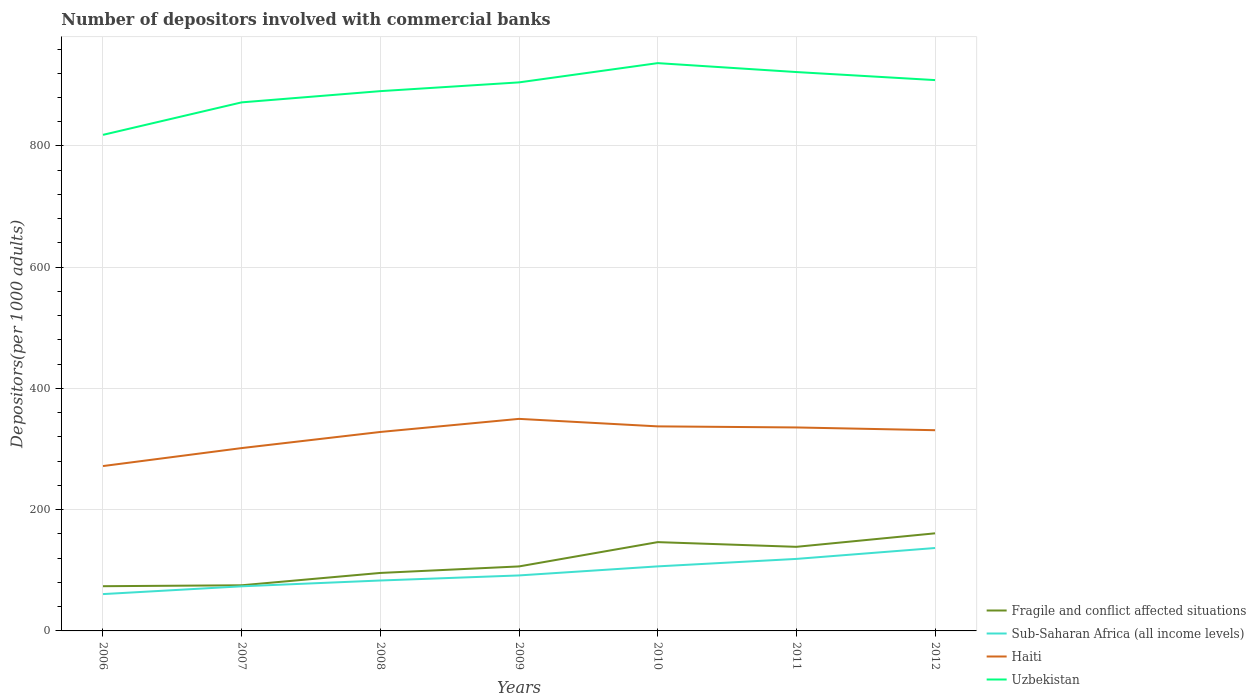How many different coloured lines are there?
Provide a succinct answer. 4. Does the line corresponding to Sub-Saharan Africa (all income levels) intersect with the line corresponding to Uzbekistan?
Your answer should be very brief. No. Across all years, what is the maximum number of depositors involved with commercial banks in Sub-Saharan Africa (all income levels)?
Your response must be concise. 60.76. What is the total number of depositors involved with commercial banks in Sub-Saharan Africa (all income levels) in the graph?
Make the answer very short. -45.73. What is the difference between the highest and the second highest number of depositors involved with commercial banks in Uzbekistan?
Give a very brief answer. 118.34. Are the values on the major ticks of Y-axis written in scientific E-notation?
Provide a short and direct response. No. Where does the legend appear in the graph?
Provide a short and direct response. Bottom right. How many legend labels are there?
Offer a terse response. 4. How are the legend labels stacked?
Your answer should be very brief. Vertical. What is the title of the graph?
Ensure brevity in your answer.  Number of depositors involved with commercial banks. What is the label or title of the Y-axis?
Offer a terse response. Depositors(per 1000 adults). What is the Depositors(per 1000 adults) in Fragile and conflict affected situations in 2006?
Offer a terse response. 73.77. What is the Depositors(per 1000 adults) of Sub-Saharan Africa (all income levels) in 2006?
Provide a short and direct response. 60.76. What is the Depositors(per 1000 adults) of Haiti in 2006?
Your answer should be compact. 271.98. What is the Depositors(per 1000 adults) of Uzbekistan in 2006?
Your answer should be compact. 818.38. What is the Depositors(per 1000 adults) in Fragile and conflict affected situations in 2007?
Provide a short and direct response. 75.3. What is the Depositors(per 1000 adults) in Sub-Saharan Africa (all income levels) in 2007?
Make the answer very short. 73.6. What is the Depositors(per 1000 adults) of Haiti in 2007?
Keep it short and to the point. 301.64. What is the Depositors(per 1000 adults) in Uzbekistan in 2007?
Ensure brevity in your answer.  871.99. What is the Depositors(per 1000 adults) of Fragile and conflict affected situations in 2008?
Your answer should be compact. 95.65. What is the Depositors(per 1000 adults) in Sub-Saharan Africa (all income levels) in 2008?
Give a very brief answer. 83.18. What is the Depositors(per 1000 adults) in Haiti in 2008?
Make the answer very short. 328.23. What is the Depositors(per 1000 adults) of Uzbekistan in 2008?
Your response must be concise. 890.51. What is the Depositors(per 1000 adults) in Fragile and conflict affected situations in 2009?
Make the answer very short. 106.41. What is the Depositors(per 1000 adults) in Sub-Saharan Africa (all income levels) in 2009?
Offer a very short reply. 91.54. What is the Depositors(per 1000 adults) in Haiti in 2009?
Make the answer very short. 349.83. What is the Depositors(per 1000 adults) of Uzbekistan in 2009?
Give a very brief answer. 904.94. What is the Depositors(per 1000 adults) of Fragile and conflict affected situations in 2010?
Your answer should be very brief. 146.5. What is the Depositors(per 1000 adults) of Sub-Saharan Africa (all income levels) in 2010?
Ensure brevity in your answer.  106.49. What is the Depositors(per 1000 adults) in Haiti in 2010?
Your answer should be very brief. 337.45. What is the Depositors(per 1000 adults) of Uzbekistan in 2010?
Keep it short and to the point. 936.72. What is the Depositors(per 1000 adults) of Fragile and conflict affected situations in 2011?
Give a very brief answer. 138.74. What is the Depositors(per 1000 adults) in Sub-Saharan Africa (all income levels) in 2011?
Offer a terse response. 118.8. What is the Depositors(per 1000 adults) in Haiti in 2011?
Offer a very short reply. 335.67. What is the Depositors(per 1000 adults) in Uzbekistan in 2011?
Your response must be concise. 921.99. What is the Depositors(per 1000 adults) in Fragile and conflict affected situations in 2012?
Ensure brevity in your answer.  161.02. What is the Depositors(per 1000 adults) in Sub-Saharan Africa (all income levels) in 2012?
Your response must be concise. 136.78. What is the Depositors(per 1000 adults) of Haiti in 2012?
Offer a very short reply. 331.14. What is the Depositors(per 1000 adults) in Uzbekistan in 2012?
Give a very brief answer. 908.73. Across all years, what is the maximum Depositors(per 1000 adults) of Fragile and conflict affected situations?
Offer a terse response. 161.02. Across all years, what is the maximum Depositors(per 1000 adults) in Sub-Saharan Africa (all income levels)?
Offer a very short reply. 136.78. Across all years, what is the maximum Depositors(per 1000 adults) in Haiti?
Offer a terse response. 349.83. Across all years, what is the maximum Depositors(per 1000 adults) in Uzbekistan?
Ensure brevity in your answer.  936.72. Across all years, what is the minimum Depositors(per 1000 adults) in Fragile and conflict affected situations?
Your answer should be very brief. 73.77. Across all years, what is the minimum Depositors(per 1000 adults) in Sub-Saharan Africa (all income levels)?
Provide a short and direct response. 60.76. Across all years, what is the minimum Depositors(per 1000 adults) of Haiti?
Your answer should be very brief. 271.98. Across all years, what is the minimum Depositors(per 1000 adults) of Uzbekistan?
Keep it short and to the point. 818.38. What is the total Depositors(per 1000 adults) of Fragile and conflict affected situations in the graph?
Offer a terse response. 797.39. What is the total Depositors(per 1000 adults) of Sub-Saharan Africa (all income levels) in the graph?
Your answer should be very brief. 671.16. What is the total Depositors(per 1000 adults) of Haiti in the graph?
Your response must be concise. 2255.95. What is the total Depositors(per 1000 adults) of Uzbekistan in the graph?
Keep it short and to the point. 6253.24. What is the difference between the Depositors(per 1000 adults) of Fragile and conflict affected situations in 2006 and that in 2007?
Your answer should be very brief. -1.53. What is the difference between the Depositors(per 1000 adults) in Sub-Saharan Africa (all income levels) in 2006 and that in 2007?
Offer a very short reply. -12.83. What is the difference between the Depositors(per 1000 adults) of Haiti in 2006 and that in 2007?
Keep it short and to the point. -29.66. What is the difference between the Depositors(per 1000 adults) of Uzbekistan in 2006 and that in 2007?
Give a very brief answer. -53.61. What is the difference between the Depositors(per 1000 adults) in Fragile and conflict affected situations in 2006 and that in 2008?
Offer a very short reply. -21.88. What is the difference between the Depositors(per 1000 adults) of Sub-Saharan Africa (all income levels) in 2006 and that in 2008?
Provide a short and direct response. -22.41. What is the difference between the Depositors(per 1000 adults) of Haiti in 2006 and that in 2008?
Ensure brevity in your answer.  -56.25. What is the difference between the Depositors(per 1000 adults) in Uzbekistan in 2006 and that in 2008?
Give a very brief answer. -72.13. What is the difference between the Depositors(per 1000 adults) in Fragile and conflict affected situations in 2006 and that in 2009?
Make the answer very short. -32.64. What is the difference between the Depositors(per 1000 adults) in Sub-Saharan Africa (all income levels) in 2006 and that in 2009?
Provide a short and direct response. -30.78. What is the difference between the Depositors(per 1000 adults) in Haiti in 2006 and that in 2009?
Your answer should be compact. -77.85. What is the difference between the Depositors(per 1000 adults) in Uzbekistan in 2006 and that in 2009?
Your answer should be very brief. -86.56. What is the difference between the Depositors(per 1000 adults) of Fragile and conflict affected situations in 2006 and that in 2010?
Provide a short and direct response. -72.73. What is the difference between the Depositors(per 1000 adults) of Sub-Saharan Africa (all income levels) in 2006 and that in 2010?
Your answer should be very brief. -45.73. What is the difference between the Depositors(per 1000 adults) of Haiti in 2006 and that in 2010?
Give a very brief answer. -65.47. What is the difference between the Depositors(per 1000 adults) of Uzbekistan in 2006 and that in 2010?
Provide a short and direct response. -118.34. What is the difference between the Depositors(per 1000 adults) of Fragile and conflict affected situations in 2006 and that in 2011?
Give a very brief answer. -64.97. What is the difference between the Depositors(per 1000 adults) of Sub-Saharan Africa (all income levels) in 2006 and that in 2011?
Your answer should be compact. -58.04. What is the difference between the Depositors(per 1000 adults) of Haiti in 2006 and that in 2011?
Your response must be concise. -63.69. What is the difference between the Depositors(per 1000 adults) of Uzbekistan in 2006 and that in 2011?
Ensure brevity in your answer.  -103.61. What is the difference between the Depositors(per 1000 adults) of Fragile and conflict affected situations in 2006 and that in 2012?
Offer a very short reply. -87.25. What is the difference between the Depositors(per 1000 adults) in Sub-Saharan Africa (all income levels) in 2006 and that in 2012?
Keep it short and to the point. -76.02. What is the difference between the Depositors(per 1000 adults) of Haiti in 2006 and that in 2012?
Ensure brevity in your answer.  -59.15. What is the difference between the Depositors(per 1000 adults) in Uzbekistan in 2006 and that in 2012?
Provide a short and direct response. -90.35. What is the difference between the Depositors(per 1000 adults) of Fragile and conflict affected situations in 2007 and that in 2008?
Offer a terse response. -20.35. What is the difference between the Depositors(per 1000 adults) of Sub-Saharan Africa (all income levels) in 2007 and that in 2008?
Give a very brief answer. -9.58. What is the difference between the Depositors(per 1000 adults) of Haiti in 2007 and that in 2008?
Give a very brief answer. -26.58. What is the difference between the Depositors(per 1000 adults) of Uzbekistan in 2007 and that in 2008?
Provide a succinct answer. -18.52. What is the difference between the Depositors(per 1000 adults) of Fragile and conflict affected situations in 2007 and that in 2009?
Your answer should be compact. -31.11. What is the difference between the Depositors(per 1000 adults) in Sub-Saharan Africa (all income levels) in 2007 and that in 2009?
Ensure brevity in your answer.  -17.95. What is the difference between the Depositors(per 1000 adults) of Haiti in 2007 and that in 2009?
Make the answer very short. -48.19. What is the difference between the Depositors(per 1000 adults) of Uzbekistan in 2007 and that in 2009?
Your answer should be very brief. -32.96. What is the difference between the Depositors(per 1000 adults) of Fragile and conflict affected situations in 2007 and that in 2010?
Make the answer very short. -71.2. What is the difference between the Depositors(per 1000 adults) in Sub-Saharan Africa (all income levels) in 2007 and that in 2010?
Keep it short and to the point. -32.89. What is the difference between the Depositors(per 1000 adults) of Haiti in 2007 and that in 2010?
Your response must be concise. -35.81. What is the difference between the Depositors(per 1000 adults) of Uzbekistan in 2007 and that in 2010?
Give a very brief answer. -64.73. What is the difference between the Depositors(per 1000 adults) of Fragile and conflict affected situations in 2007 and that in 2011?
Provide a succinct answer. -63.44. What is the difference between the Depositors(per 1000 adults) of Sub-Saharan Africa (all income levels) in 2007 and that in 2011?
Your answer should be compact. -45.21. What is the difference between the Depositors(per 1000 adults) of Haiti in 2007 and that in 2011?
Keep it short and to the point. -34.03. What is the difference between the Depositors(per 1000 adults) in Uzbekistan in 2007 and that in 2011?
Ensure brevity in your answer.  -50. What is the difference between the Depositors(per 1000 adults) of Fragile and conflict affected situations in 2007 and that in 2012?
Offer a terse response. -85.72. What is the difference between the Depositors(per 1000 adults) of Sub-Saharan Africa (all income levels) in 2007 and that in 2012?
Your answer should be compact. -63.19. What is the difference between the Depositors(per 1000 adults) of Haiti in 2007 and that in 2012?
Ensure brevity in your answer.  -29.49. What is the difference between the Depositors(per 1000 adults) in Uzbekistan in 2007 and that in 2012?
Ensure brevity in your answer.  -36.74. What is the difference between the Depositors(per 1000 adults) of Fragile and conflict affected situations in 2008 and that in 2009?
Offer a very short reply. -10.75. What is the difference between the Depositors(per 1000 adults) of Sub-Saharan Africa (all income levels) in 2008 and that in 2009?
Provide a short and direct response. -8.37. What is the difference between the Depositors(per 1000 adults) of Haiti in 2008 and that in 2009?
Offer a very short reply. -21.61. What is the difference between the Depositors(per 1000 adults) in Uzbekistan in 2008 and that in 2009?
Give a very brief answer. -14.44. What is the difference between the Depositors(per 1000 adults) in Fragile and conflict affected situations in 2008 and that in 2010?
Your answer should be very brief. -50.84. What is the difference between the Depositors(per 1000 adults) in Sub-Saharan Africa (all income levels) in 2008 and that in 2010?
Offer a terse response. -23.31. What is the difference between the Depositors(per 1000 adults) in Haiti in 2008 and that in 2010?
Give a very brief answer. -9.23. What is the difference between the Depositors(per 1000 adults) in Uzbekistan in 2008 and that in 2010?
Ensure brevity in your answer.  -46.21. What is the difference between the Depositors(per 1000 adults) of Fragile and conflict affected situations in 2008 and that in 2011?
Offer a terse response. -43.09. What is the difference between the Depositors(per 1000 adults) in Sub-Saharan Africa (all income levels) in 2008 and that in 2011?
Ensure brevity in your answer.  -35.63. What is the difference between the Depositors(per 1000 adults) in Haiti in 2008 and that in 2011?
Your answer should be compact. -7.44. What is the difference between the Depositors(per 1000 adults) of Uzbekistan in 2008 and that in 2011?
Offer a very short reply. -31.48. What is the difference between the Depositors(per 1000 adults) of Fragile and conflict affected situations in 2008 and that in 2012?
Make the answer very short. -65.37. What is the difference between the Depositors(per 1000 adults) in Sub-Saharan Africa (all income levels) in 2008 and that in 2012?
Provide a short and direct response. -53.61. What is the difference between the Depositors(per 1000 adults) in Haiti in 2008 and that in 2012?
Your response must be concise. -2.91. What is the difference between the Depositors(per 1000 adults) in Uzbekistan in 2008 and that in 2012?
Provide a short and direct response. -18.22. What is the difference between the Depositors(per 1000 adults) in Fragile and conflict affected situations in 2009 and that in 2010?
Your response must be concise. -40.09. What is the difference between the Depositors(per 1000 adults) of Sub-Saharan Africa (all income levels) in 2009 and that in 2010?
Keep it short and to the point. -14.95. What is the difference between the Depositors(per 1000 adults) in Haiti in 2009 and that in 2010?
Your response must be concise. 12.38. What is the difference between the Depositors(per 1000 adults) of Uzbekistan in 2009 and that in 2010?
Your answer should be compact. -31.77. What is the difference between the Depositors(per 1000 adults) in Fragile and conflict affected situations in 2009 and that in 2011?
Make the answer very short. -32.34. What is the difference between the Depositors(per 1000 adults) of Sub-Saharan Africa (all income levels) in 2009 and that in 2011?
Give a very brief answer. -27.26. What is the difference between the Depositors(per 1000 adults) in Haiti in 2009 and that in 2011?
Make the answer very short. 14.17. What is the difference between the Depositors(per 1000 adults) in Uzbekistan in 2009 and that in 2011?
Offer a very short reply. -17.04. What is the difference between the Depositors(per 1000 adults) of Fragile and conflict affected situations in 2009 and that in 2012?
Your answer should be very brief. -54.61. What is the difference between the Depositors(per 1000 adults) in Sub-Saharan Africa (all income levels) in 2009 and that in 2012?
Your answer should be compact. -45.24. What is the difference between the Depositors(per 1000 adults) of Haiti in 2009 and that in 2012?
Offer a very short reply. 18.7. What is the difference between the Depositors(per 1000 adults) in Uzbekistan in 2009 and that in 2012?
Ensure brevity in your answer.  -3.78. What is the difference between the Depositors(per 1000 adults) of Fragile and conflict affected situations in 2010 and that in 2011?
Provide a succinct answer. 7.75. What is the difference between the Depositors(per 1000 adults) in Sub-Saharan Africa (all income levels) in 2010 and that in 2011?
Offer a very short reply. -12.31. What is the difference between the Depositors(per 1000 adults) in Haiti in 2010 and that in 2011?
Your answer should be very brief. 1.79. What is the difference between the Depositors(per 1000 adults) in Uzbekistan in 2010 and that in 2011?
Your answer should be compact. 14.73. What is the difference between the Depositors(per 1000 adults) in Fragile and conflict affected situations in 2010 and that in 2012?
Your response must be concise. -14.52. What is the difference between the Depositors(per 1000 adults) in Sub-Saharan Africa (all income levels) in 2010 and that in 2012?
Provide a succinct answer. -30.29. What is the difference between the Depositors(per 1000 adults) of Haiti in 2010 and that in 2012?
Make the answer very short. 6.32. What is the difference between the Depositors(per 1000 adults) in Uzbekistan in 2010 and that in 2012?
Ensure brevity in your answer.  27.99. What is the difference between the Depositors(per 1000 adults) in Fragile and conflict affected situations in 2011 and that in 2012?
Make the answer very short. -22.28. What is the difference between the Depositors(per 1000 adults) in Sub-Saharan Africa (all income levels) in 2011 and that in 2012?
Give a very brief answer. -17.98. What is the difference between the Depositors(per 1000 adults) in Haiti in 2011 and that in 2012?
Give a very brief answer. 4.53. What is the difference between the Depositors(per 1000 adults) in Uzbekistan in 2011 and that in 2012?
Provide a short and direct response. 13.26. What is the difference between the Depositors(per 1000 adults) of Fragile and conflict affected situations in 2006 and the Depositors(per 1000 adults) of Sub-Saharan Africa (all income levels) in 2007?
Ensure brevity in your answer.  0.17. What is the difference between the Depositors(per 1000 adults) in Fragile and conflict affected situations in 2006 and the Depositors(per 1000 adults) in Haiti in 2007?
Ensure brevity in your answer.  -227.88. What is the difference between the Depositors(per 1000 adults) in Fragile and conflict affected situations in 2006 and the Depositors(per 1000 adults) in Uzbekistan in 2007?
Your response must be concise. -798.22. What is the difference between the Depositors(per 1000 adults) of Sub-Saharan Africa (all income levels) in 2006 and the Depositors(per 1000 adults) of Haiti in 2007?
Provide a short and direct response. -240.88. What is the difference between the Depositors(per 1000 adults) in Sub-Saharan Africa (all income levels) in 2006 and the Depositors(per 1000 adults) in Uzbekistan in 2007?
Make the answer very short. -811.22. What is the difference between the Depositors(per 1000 adults) of Haiti in 2006 and the Depositors(per 1000 adults) of Uzbekistan in 2007?
Make the answer very short. -600. What is the difference between the Depositors(per 1000 adults) in Fragile and conflict affected situations in 2006 and the Depositors(per 1000 adults) in Sub-Saharan Africa (all income levels) in 2008?
Make the answer very short. -9.41. What is the difference between the Depositors(per 1000 adults) in Fragile and conflict affected situations in 2006 and the Depositors(per 1000 adults) in Haiti in 2008?
Ensure brevity in your answer.  -254.46. What is the difference between the Depositors(per 1000 adults) of Fragile and conflict affected situations in 2006 and the Depositors(per 1000 adults) of Uzbekistan in 2008?
Provide a short and direct response. -816.74. What is the difference between the Depositors(per 1000 adults) in Sub-Saharan Africa (all income levels) in 2006 and the Depositors(per 1000 adults) in Haiti in 2008?
Keep it short and to the point. -267.47. What is the difference between the Depositors(per 1000 adults) in Sub-Saharan Africa (all income levels) in 2006 and the Depositors(per 1000 adults) in Uzbekistan in 2008?
Offer a terse response. -829.74. What is the difference between the Depositors(per 1000 adults) of Haiti in 2006 and the Depositors(per 1000 adults) of Uzbekistan in 2008?
Your answer should be compact. -618.52. What is the difference between the Depositors(per 1000 adults) in Fragile and conflict affected situations in 2006 and the Depositors(per 1000 adults) in Sub-Saharan Africa (all income levels) in 2009?
Your response must be concise. -17.78. What is the difference between the Depositors(per 1000 adults) of Fragile and conflict affected situations in 2006 and the Depositors(per 1000 adults) of Haiti in 2009?
Your answer should be very brief. -276.07. What is the difference between the Depositors(per 1000 adults) in Fragile and conflict affected situations in 2006 and the Depositors(per 1000 adults) in Uzbekistan in 2009?
Provide a succinct answer. -831.17. What is the difference between the Depositors(per 1000 adults) of Sub-Saharan Africa (all income levels) in 2006 and the Depositors(per 1000 adults) of Haiti in 2009?
Keep it short and to the point. -289.07. What is the difference between the Depositors(per 1000 adults) of Sub-Saharan Africa (all income levels) in 2006 and the Depositors(per 1000 adults) of Uzbekistan in 2009?
Offer a terse response. -844.18. What is the difference between the Depositors(per 1000 adults) in Haiti in 2006 and the Depositors(per 1000 adults) in Uzbekistan in 2009?
Your answer should be compact. -632.96. What is the difference between the Depositors(per 1000 adults) of Fragile and conflict affected situations in 2006 and the Depositors(per 1000 adults) of Sub-Saharan Africa (all income levels) in 2010?
Give a very brief answer. -32.72. What is the difference between the Depositors(per 1000 adults) of Fragile and conflict affected situations in 2006 and the Depositors(per 1000 adults) of Haiti in 2010?
Give a very brief answer. -263.69. What is the difference between the Depositors(per 1000 adults) of Fragile and conflict affected situations in 2006 and the Depositors(per 1000 adults) of Uzbekistan in 2010?
Make the answer very short. -862.95. What is the difference between the Depositors(per 1000 adults) in Sub-Saharan Africa (all income levels) in 2006 and the Depositors(per 1000 adults) in Haiti in 2010?
Offer a terse response. -276.69. What is the difference between the Depositors(per 1000 adults) of Sub-Saharan Africa (all income levels) in 2006 and the Depositors(per 1000 adults) of Uzbekistan in 2010?
Offer a terse response. -875.95. What is the difference between the Depositors(per 1000 adults) of Haiti in 2006 and the Depositors(per 1000 adults) of Uzbekistan in 2010?
Ensure brevity in your answer.  -664.73. What is the difference between the Depositors(per 1000 adults) of Fragile and conflict affected situations in 2006 and the Depositors(per 1000 adults) of Sub-Saharan Africa (all income levels) in 2011?
Your response must be concise. -45.04. What is the difference between the Depositors(per 1000 adults) of Fragile and conflict affected situations in 2006 and the Depositors(per 1000 adults) of Haiti in 2011?
Offer a very short reply. -261.9. What is the difference between the Depositors(per 1000 adults) in Fragile and conflict affected situations in 2006 and the Depositors(per 1000 adults) in Uzbekistan in 2011?
Provide a succinct answer. -848.22. What is the difference between the Depositors(per 1000 adults) of Sub-Saharan Africa (all income levels) in 2006 and the Depositors(per 1000 adults) of Haiti in 2011?
Provide a succinct answer. -274.91. What is the difference between the Depositors(per 1000 adults) in Sub-Saharan Africa (all income levels) in 2006 and the Depositors(per 1000 adults) in Uzbekistan in 2011?
Provide a short and direct response. -861.22. What is the difference between the Depositors(per 1000 adults) in Haiti in 2006 and the Depositors(per 1000 adults) in Uzbekistan in 2011?
Keep it short and to the point. -650. What is the difference between the Depositors(per 1000 adults) in Fragile and conflict affected situations in 2006 and the Depositors(per 1000 adults) in Sub-Saharan Africa (all income levels) in 2012?
Keep it short and to the point. -63.02. What is the difference between the Depositors(per 1000 adults) of Fragile and conflict affected situations in 2006 and the Depositors(per 1000 adults) of Haiti in 2012?
Your response must be concise. -257.37. What is the difference between the Depositors(per 1000 adults) in Fragile and conflict affected situations in 2006 and the Depositors(per 1000 adults) in Uzbekistan in 2012?
Keep it short and to the point. -834.96. What is the difference between the Depositors(per 1000 adults) of Sub-Saharan Africa (all income levels) in 2006 and the Depositors(per 1000 adults) of Haiti in 2012?
Make the answer very short. -270.38. What is the difference between the Depositors(per 1000 adults) in Sub-Saharan Africa (all income levels) in 2006 and the Depositors(per 1000 adults) in Uzbekistan in 2012?
Make the answer very short. -847.96. What is the difference between the Depositors(per 1000 adults) in Haiti in 2006 and the Depositors(per 1000 adults) in Uzbekistan in 2012?
Offer a very short reply. -636.74. What is the difference between the Depositors(per 1000 adults) of Fragile and conflict affected situations in 2007 and the Depositors(per 1000 adults) of Sub-Saharan Africa (all income levels) in 2008?
Offer a terse response. -7.88. What is the difference between the Depositors(per 1000 adults) of Fragile and conflict affected situations in 2007 and the Depositors(per 1000 adults) of Haiti in 2008?
Make the answer very short. -252.93. What is the difference between the Depositors(per 1000 adults) of Fragile and conflict affected situations in 2007 and the Depositors(per 1000 adults) of Uzbekistan in 2008?
Your answer should be very brief. -815.21. What is the difference between the Depositors(per 1000 adults) of Sub-Saharan Africa (all income levels) in 2007 and the Depositors(per 1000 adults) of Haiti in 2008?
Your response must be concise. -254.63. What is the difference between the Depositors(per 1000 adults) in Sub-Saharan Africa (all income levels) in 2007 and the Depositors(per 1000 adults) in Uzbekistan in 2008?
Your response must be concise. -816.91. What is the difference between the Depositors(per 1000 adults) of Haiti in 2007 and the Depositors(per 1000 adults) of Uzbekistan in 2008?
Provide a short and direct response. -588.86. What is the difference between the Depositors(per 1000 adults) of Fragile and conflict affected situations in 2007 and the Depositors(per 1000 adults) of Sub-Saharan Africa (all income levels) in 2009?
Provide a succinct answer. -16.24. What is the difference between the Depositors(per 1000 adults) in Fragile and conflict affected situations in 2007 and the Depositors(per 1000 adults) in Haiti in 2009?
Ensure brevity in your answer.  -274.54. What is the difference between the Depositors(per 1000 adults) in Fragile and conflict affected situations in 2007 and the Depositors(per 1000 adults) in Uzbekistan in 2009?
Your answer should be compact. -829.64. What is the difference between the Depositors(per 1000 adults) in Sub-Saharan Africa (all income levels) in 2007 and the Depositors(per 1000 adults) in Haiti in 2009?
Ensure brevity in your answer.  -276.24. What is the difference between the Depositors(per 1000 adults) in Sub-Saharan Africa (all income levels) in 2007 and the Depositors(per 1000 adults) in Uzbekistan in 2009?
Your answer should be compact. -831.35. What is the difference between the Depositors(per 1000 adults) of Haiti in 2007 and the Depositors(per 1000 adults) of Uzbekistan in 2009?
Provide a succinct answer. -603.3. What is the difference between the Depositors(per 1000 adults) of Fragile and conflict affected situations in 2007 and the Depositors(per 1000 adults) of Sub-Saharan Africa (all income levels) in 2010?
Provide a succinct answer. -31.19. What is the difference between the Depositors(per 1000 adults) in Fragile and conflict affected situations in 2007 and the Depositors(per 1000 adults) in Haiti in 2010?
Your response must be concise. -262.15. What is the difference between the Depositors(per 1000 adults) of Fragile and conflict affected situations in 2007 and the Depositors(per 1000 adults) of Uzbekistan in 2010?
Offer a terse response. -861.42. What is the difference between the Depositors(per 1000 adults) of Sub-Saharan Africa (all income levels) in 2007 and the Depositors(per 1000 adults) of Haiti in 2010?
Provide a short and direct response. -263.86. What is the difference between the Depositors(per 1000 adults) of Sub-Saharan Africa (all income levels) in 2007 and the Depositors(per 1000 adults) of Uzbekistan in 2010?
Make the answer very short. -863.12. What is the difference between the Depositors(per 1000 adults) in Haiti in 2007 and the Depositors(per 1000 adults) in Uzbekistan in 2010?
Your answer should be compact. -635.07. What is the difference between the Depositors(per 1000 adults) in Fragile and conflict affected situations in 2007 and the Depositors(per 1000 adults) in Sub-Saharan Africa (all income levels) in 2011?
Your answer should be compact. -43.51. What is the difference between the Depositors(per 1000 adults) in Fragile and conflict affected situations in 2007 and the Depositors(per 1000 adults) in Haiti in 2011?
Provide a succinct answer. -260.37. What is the difference between the Depositors(per 1000 adults) in Fragile and conflict affected situations in 2007 and the Depositors(per 1000 adults) in Uzbekistan in 2011?
Your response must be concise. -846.69. What is the difference between the Depositors(per 1000 adults) in Sub-Saharan Africa (all income levels) in 2007 and the Depositors(per 1000 adults) in Haiti in 2011?
Ensure brevity in your answer.  -262.07. What is the difference between the Depositors(per 1000 adults) in Sub-Saharan Africa (all income levels) in 2007 and the Depositors(per 1000 adults) in Uzbekistan in 2011?
Your answer should be very brief. -848.39. What is the difference between the Depositors(per 1000 adults) of Haiti in 2007 and the Depositors(per 1000 adults) of Uzbekistan in 2011?
Your answer should be very brief. -620.34. What is the difference between the Depositors(per 1000 adults) of Fragile and conflict affected situations in 2007 and the Depositors(per 1000 adults) of Sub-Saharan Africa (all income levels) in 2012?
Offer a terse response. -61.49. What is the difference between the Depositors(per 1000 adults) in Fragile and conflict affected situations in 2007 and the Depositors(per 1000 adults) in Haiti in 2012?
Keep it short and to the point. -255.84. What is the difference between the Depositors(per 1000 adults) of Fragile and conflict affected situations in 2007 and the Depositors(per 1000 adults) of Uzbekistan in 2012?
Your response must be concise. -833.43. What is the difference between the Depositors(per 1000 adults) of Sub-Saharan Africa (all income levels) in 2007 and the Depositors(per 1000 adults) of Haiti in 2012?
Your answer should be very brief. -257.54. What is the difference between the Depositors(per 1000 adults) of Sub-Saharan Africa (all income levels) in 2007 and the Depositors(per 1000 adults) of Uzbekistan in 2012?
Ensure brevity in your answer.  -835.13. What is the difference between the Depositors(per 1000 adults) of Haiti in 2007 and the Depositors(per 1000 adults) of Uzbekistan in 2012?
Provide a succinct answer. -607.08. What is the difference between the Depositors(per 1000 adults) of Fragile and conflict affected situations in 2008 and the Depositors(per 1000 adults) of Sub-Saharan Africa (all income levels) in 2009?
Provide a succinct answer. 4.11. What is the difference between the Depositors(per 1000 adults) of Fragile and conflict affected situations in 2008 and the Depositors(per 1000 adults) of Haiti in 2009?
Keep it short and to the point. -254.18. What is the difference between the Depositors(per 1000 adults) of Fragile and conflict affected situations in 2008 and the Depositors(per 1000 adults) of Uzbekistan in 2009?
Your answer should be very brief. -809.29. What is the difference between the Depositors(per 1000 adults) in Sub-Saharan Africa (all income levels) in 2008 and the Depositors(per 1000 adults) in Haiti in 2009?
Offer a terse response. -266.66. What is the difference between the Depositors(per 1000 adults) of Sub-Saharan Africa (all income levels) in 2008 and the Depositors(per 1000 adults) of Uzbekistan in 2009?
Offer a terse response. -821.77. What is the difference between the Depositors(per 1000 adults) of Haiti in 2008 and the Depositors(per 1000 adults) of Uzbekistan in 2009?
Offer a very short reply. -576.71. What is the difference between the Depositors(per 1000 adults) of Fragile and conflict affected situations in 2008 and the Depositors(per 1000 adults) of Sub-Saharan Africa (all income levels) in 2010?
Keep it short and to the point. -10.84. What is the difference between the Depositors(per 1000 adults) of Fragile and conflict affected situations in 2008 and the Depositors(per 1000 adults) of Haiti in 2010?
Your answer should be very brief. -241.8. What is the difference between the Depositors(per 1000 adults) of Fragile and conflict affected situations in 2008 and the Depositors(per 1000 adults) of Uzbekistan in 2010?
Keep it short and to the point. -841.07. What is the difference between the Depositors(per 1000 adults) in Sub-Saharan Africa (all income levels) in 2008 and the Depositors(per 1000 adults) in Haiti in 2010?
Offer a terse response. -254.28. What is the difference between the Depositors(per 1000 adults) in Sub-Saharan Africa (all income levels) in 2008 and the Depositors(per 1000 adults) in Uzbekistan in 2010?
Your answer should be very brief. -853.54. What is the difference between the Depositors(per 1000 adults) of Haiti in 2008 and the Depositors(per 1000 adults) of Uzbekistan in 2010?
Offer a very short reply. -608.49. What is the difference between the Depositors(per 1000 adults) in Fragile and conflict affected situations in 2008 and the Depositors(per 1000 adults) in Sub-Saharan Africa (all income levels) in 2011?
Your answer should be compact. -23.15. What is the difference between the Depositors(per 1000 adults) in Fragile and conflict affected situations in 2008 and the Depositors(per 1000 adults) in Haiti in 2011?
Your answer should be very brief. -240.02. What is the difference between the Depositors(per 1000 adults) in Fragile and conflict affected situations in 2008 and the Depositors(per 1000 adults) in Uzbekistan in 2011?
Provide a succinct answer. -826.34. What is the difference between the Depositors(per 1000 adults) of Sub-Saharan Africa (all income levels) in 2008 and the Depositors(per 1000 adults) of Haiti in 2011?
Your response must be concise. -252.49. What is the difference between the Depositors(per 1000 adults) of Sub-Saharan Africa (all income levels) in 2008 and the Depositors(per 1000 adults) of Uzbekistan in 2011?
Give a very brief answer. -838.81. What is the difference between the Depositors(per 1000 adults) of Haiti in 2008 and the Depositors(per 1000 adults) of Uzbekistan in 2011?
Keep it short and to the point. -593.76. What is the difference between the Depositors(per 1000 adults) of Fragile and conflict affected situations in 2008 and the Depositors(per 1000 adults) of Sub-Saharan Africa (all income levels) in 2012?
Give a very brief answer. -41.13. What is the difference between the Depositors(per 1000 adults) of Fragile and conflict affected situations in 2008 and the Depositors(per 1000 adults) of Haiti in 2012?
Make the answer very short. -235.49. What is the difference between the Depositors(per 1000 adults) of Fragile and conflict affected situations in 2008 and the Depositors(per 1000 adults) of Uzbekistan in 2012?
Provide a short and direct response. -813.08. What is the difference between the Depositors(per 1000 adults) of Sub-Saharan Africa (all income levels) in 2008 and the Depositors(per 1000 adults) of Haiti in 2012?
Make the answer very short. -247.96. What is the difference between the Depositors(per 1000 adults) in Sub-Saharan Africa (all income levels) in 2008 and the Depositors(per 1000 adults) in Uzbekistan in 2012?
Provide a short and direct response. -825.55. What is the difference between the Depositors(per 1000 adults) of Haiti in 2008 and the Depositors(per 1000 adults) of Uzbekistan in 2012?
Your response must be concise. -580.5. What is the difference between the Depositors(per 1000 adults) in Fragile and conflict affected situations in 2009 and the Depositors(per 1000 adults) in Sub-Saharan Africa (all income levels) in 2010?
Your response must be concise. -0.08. What is the difference between the Depositors(per 1000 adults) in Fragile and conflict affected situations in 2009 and the Depositors(per 1000 adults) in Haiti in 2010?
Offer a very short reply. -231.05. What is the difference between the Depositors(per 1000 adults) of Fragile and conflict affected situations in 2009 and the Depositors(per 1000 adults) of Uzbekistan in 2010?
Provide a succinct answer. -830.31. What is the difference between the Depositors(per 1000 adults) in Sub-Saharan Africa (all income levels) in 2009 and the Depositors(per 1000 adults) in Haiti in 2010?
Make the answer very short. -245.91. What is the difference between the Depositors(per 1000 adults) of Sub-Saharan Africa (all income levels) in 2009 and the Depositors(per 1000 adults) of Uzbekistan in 2010?
Keep it short and to the point. -845.17. What is the difference between the Depositors(per 1000 adults) of Haiti in 2009 and the Depositors(per 1000 adults) of Uzbekistan in 2010?
Ensure brevity in your answer.  -586.88. What is the difference between the Depositors(per 1000 adults) in Fragile and conflict affected situations in 2009 and the Depositors(per 1000 adults) in Sub-Saharan Africa (all income levels) in 2011?
Your response must be concise. -12.4. What is the difference between the Depositors(per 1000 adults) of Fragile and conflict affected situations in 2009 and the Depositors(per 1000 adults) of Haiti in 2011?
Provide a short and direct response. -229.26. What is the difference between the Depositors(per 1000 adults) in Fragile and conflict affected situations in 2009 and the Depositors(per 1000 adults) in Uzbekistan in 2011?
Offer a very short reply. -815.58. What is the difference between the Depositors(per 1000 adults) of Sub-Saharan Africa (all income levels) in 2009 and the Depositors(per 1000 adults) of Haiti in 2011?
Your answer should be very brief. -244.13. What is the difference between the Depositors(per 1000 adults) of Sub-Saharan Africa (all income levels) in 2009 and the Depositors(per 1000 adults) of Uzbekistan in 2011?
Your response must be concise. -830.44. What is the difference between the Depositors(per 1000 adults) of Haiti in 2009 and the Depositors(per 1000 adults) of Uzbekistan in 2011?
Offer a terse response. -572.15. What is the difference between the Depositors(per 1000 adults) of Fragile and conflict affected situations in 2009 and the Depositors(per 1000 adults) of Sub-Saharan Africa (all income levels) in 2012?
Your answer should be very brief. -30.38. What is the difference between the Depositors(per 1000 adults) in Fragile and conflict affected situations in 2009 and the Depositors(per 1000 adults) in Haiti in 2012?
Provide a succinct answer. -224.73. What is the difference between the Depositors(per 1000 adults) of Fragile and conflict affected situations in 2009 and the Depositors(per 1000 adults) of Uzbekistan in 2012?
Your answer should be very brief. -802.32. What is the difference between the Depositors(per 1000 adults) in Sub-Saharan Africa (all income levels) in 2009 and the Depositors(per 1000 adults) in Haiti in 2012?
Offer a very short reply. -239.59. What is the difference between the Depositors(per 1000 adults) in Sub-Saharan Africa (all income levels) in 2009 and the Depositors(per 1000 adults) in Uzbekistan in 2012?
Your answer should be very brief. -817.18. What is the difference between the Depositors(per 1000 adults) in Haiti in 2009 and the Depositors(per 1000 adults) in Uzbekistan in 2012?
Your answer should be very brief. -558.89. What is the difference between the Depositors(per 1000 adults) in Fragile and conflict affected situations in 2010 and the Depositors(per 1000 adults) in Sub-Saharan Africa (all income levels) in 2011?
Your answer should be very brief. 27.69. What is the difference between the Depositors(per 1000 adults) in Fragile and conflict affected situations in 2010 and the Depositors(per 1000 adults) in Haiti in 2011?
Provide a succinct answer. -189.17. What is the difference between the Depositors(per 1000 adults) of Fragile and conflict affected situations in 2010 and the Depositors(per 1000 adults) of Uzbekistan in 2011?
Make the answer very short. -775.49. What is the difference between the Depositors(per 1000 adults) of Sub-Saharan Africa (all income levels) in 2010 and the Depositors(per 1000 adults) of Haiti in 2011?
Your answer should be compact. -229.18. What is the difference between the Depositors(per 1000 adults) of Sub-Saharan Africa (all income levels) in 2010 and the Depositors(per 1000 adults) of Uzbekistan in 2011?
Your answer should be compact. -815.5. What is the difference between the Depositors(per 1000 adults) of Haiti in 2010 and the Depositors(per 1000 adults) of Uzbekistan in 2011?
Give a very brief answer. -584.53. What is the difference between the Depositors(per 1000 adults) of Fragile and conflict affected situations in 2010 and the Depositors(per 1000 adults) of Sub-Saharan Africa (all income levels) in 2012?
Provide a succinct answer. 9.71. What is the difference between the Depositors(per 1000 adults) in Fragile and conflict affected situations in 2010 and the Depositors(per 1000 adults) in Haiti in 2012?
Offer a very short reply. -184.64. What is the difference between the Depositors(per 1000 adults) of Fragile and conflict affected situations in 2010 and the Depositors(per 1000 adults) of Uzbekistan in 2012?
Offer a very short reply. -762.23. What is the difference between the Depositors(per 1000 adults) of Sub-Saharan Africa (all income levels) in 2010 and the Depositors(per 1000 adults) of Haiti in 2012?
Keep it short and to the point. -224.65. What is the difference between the Depositors(per 1000 adults) in Sub-Saharan Africa (all income levels) in 2010 and the Depositors(per 1000 adults) in Uzbekistan in 2012?
Provide a short and direct response. -802.24. What is the difference between the Depositors(per 1000 adults) in Haiti in 2010 and the Depositors(per 1000 adults) in Uzbekistan in 2012?
Ensure brevity in your answer.  -571.27. What is the difference between the Depositors(per 1000 adults) of Fragile and conflict affected situations in 2011 and the Depositors(per 1000 adults) of Sub-Saharan Africa (all income levels) in 2012?
Your answer should be compact. 1.96. What is the difference between the Depositors(per 1000 adults) of Fragile and conflict affected situations in 2011 and the Depositors(per 1000 adults) of Haiti in 2012?
Your response must be concise. -192.39. What is the difference between the Depositors(per 1000 adults) of Fragile and conflict affected situations in 2011 and the Depositors(per 1000 adults) of Uzbekistan in 2012?
Offer a terse response. -769.98. What is the difference between the Depositors(per 1000 adults) of Sub-Saharan Africa (all income levels) in 2011 and the Depositors(per 1000 adults) of Haiti in 2012?
Ensure brevity in your answer.  -212.33. What is the difference between the Depositors(per 1000 adults) of Sub-Saharan Africa (all income levels) in 2011 and the Depositors(per 1000 adults) of Uzbekistan in 2012?
Offer a terse response. -789.92. What is the difference between the Depositors(per 1000 adults) of Haiti in 2011 and the Depositors(per 1000 adults) of Uzbekistan in 2012?
Your answer should be very brief. -573.06. What is the average Depositors(per 1000 adults) in Fragile and conflict affected situations per year?
Offer a terse response. 113.91. What is the average Depositors(per 1000 adults) in Sub-Saharan Africa (all income levels) per year?
Offer a terse response. 95.88. What is the average Depositors(per 1000 adults) of Haiti per year?
Provide a succinct answer. 322.28. What is the average Depositors(per 1000 adults) in Uzbekistan per year?
Your answer should be compact. 893.32. In the year 2006, what is the difference between the Depositors(per 1000 adults) in Fragile and conflict affected situations and Depositors(per 1000 adults) in Sub-Saharan Africa (all income levels)?
Your answer should be compact. 13.01. In the year 2006, what is the difference between the Depositors(per 1000 adults) of Fragile and conflict affected situations and Depositors(per 1000 adults) of Haiti?
Your answer should be very brief. -198.22. In the year 2006, what is the difference between the Depositors(per 1000 adults) in Fragile and conflict affected situations and Depositors(per 1000 adults) in Uzbekistan?
Make the answer very short. -744.61. In the year 2006, what is the difference between the Depositors(per 1000 adults) in Sub-Saharan Africa (all income levels) and Depositors(per 1000 adults) in Haiti?
Your response must be concise. -211.22. In the year 2006, what is the difference between the Depositors(per 1000 adults) in Sub-Saharan Africa (all income levels) and Depositors(per 1000 adults) in Uzbekistan?
Keep it short and to the point. -757.62. In the year 2006, what is the difference between the Depositors(per 1000 adults) of Haiti and Depositors(per 1000 adults) of Uzbekistan?
Your answer should be very brief. -546.4. In the year 2007, what is the difference between the Depositors(per 1000 adults) of Fragile and conflict affected situations and Depositors(per 1000 adults) of Sub-Saharan Africa (all income levels)?
Give a very brief answer. 1.7. In the year 2007, what is the difference between the Depositors(per 1000 adults) of Fragile and conflict affected situations and Depositors(per 1000 adults) of Haiti?
Provide a succinct answer. -226.34. In the year 2007, what is the difference between the Depositors(per 1000 adults) of Fragile and conflict affected situations and Depositors(per 1000 adults) of Uzbekistan?
Give a very brief answer. -796.69. In the year 2007, what is the difference between the Depositors(per 1000 adults) in Sub-Saharan Africa (all income levels) and Depositors(per 1000 adults) in Haiti?
Your answer should be compact. -228.05. In the year 2007, what is the difference between the Depositors(per 1000 adults) of Sub-Saharan Africa (all income levels) and Depositors(per 1000 adults) of Uzbekistan?
Provide a succinct answer. -798.39. In the year 2007, what is the difference between the Depositors(per 1000 adults) of Haiti and Depositors(per 1000 adults) of Uzbekistan?
Offer a terse response. -570.34. In the year 2008, what is the difference between the Depositors(per 1000 adults) of Fragile and conflict affected situations and Depositors(per 1000 adults) of Sub-Saharan Africa (all income levels)?
Your response must be concise. 12.47. In the year 2008, what is the difference between the Depositors(per 1000 adults) in Fragile and conflict affected situations and Depositors(per 1000 adults) in Haiti?
Ensure brevity in your answer.  -232.58. In the year 2008, what is the difference between the Depositors(per 1000 adults) of Fragile and conflict affected situations and Depositors(per 1000 adults) of Uzbekistan?
Your answer should be compact. -794.85. In the year 2008, what is the difference between the Depositors(per 1000 adults) in Sub-Saharan Africa (all income levels) and Depositors(per 1000 adults) in Haiti?
Ensure brevity in your answer.  -245.05. In the year 2008, what is the difference between the Depositors(per 1000 adults) of Sub-Saharan Africa (all income levels) and Depositors(per 1000 adults) of Uzbekistan?
Provide a succinct answer. -807.33. In the year 2008, what is the difference between the Depositors(per 1000 adults) of Haiti and Depositors(per 1000 adults) of Uzbekistan?
Offer a terse response. -562.28. In the year 2009, what is the difference between the Depositors(per 1000 adults) of Fragile and conflict affected situations and Depositors(per 1000 adults) of Sub-Saharan Africa (all income levels)?
Ensure brevity in your answer.  14.86. In the year 2009, what is the difference between the Depositors(per 1000 adults) in Fragile and conflict affected situations and Depositors(per 1000 adults) in Haiti?
Provide a succinct answer. -243.43. In the year 2009, what is the difference between the Depositors(per 1000 adults) in Fragile and conflict affected situations and Depositors(per 1000 adults) in Uzbekistan?
Provide a short and direct response. -798.54. In the year 2009, what is the difference between the Depositors(per 1000 adults) of Sub-Saharan Africa (all income levels) and Depositors(per 1000 adults) of Haiti?
Your answer should be very brief. -258.29. In the year 2009, what is the difference between the Depositors(per 1000 adults) in Sub-Saharan Africa (all income levels) and Depositors(per 1000 adults) in Uzbekistan?
Provide a short and direct response. -813.4. In the year 2009, what is the difference between the Depositors(per 1000 adults) of Haiti and Depositors(per 1000 adults) of Uzbekistan?
Make the answer very short. -555.11. In the year 2010, what is the difference between the Depositors(per 1000 adults) of Fragile and conflict affected situations and Depositors(per 1000 adults) of Sub-Saharan Africa (all income levels)?
Keep it short and to the point. 40.01. In the year 2010, what is the difference between the Depositors(per 1000 adults) of Fragile and conflict affected situations and Depositors(per 1000 adults) of Haiti?
Offer a very short reply. -190.96. In the year 2010, what is the difference between the Depositors(per 1000 adults) in Fragile and conflict affected situations and Depositors(per 1000 adults) in Uzbekistan?
Make the answer very short. -790.22. In the year 2010, what is the difference between the Depositors(per 1000 adults) of Sub-Saharan Africa (all income levels) and Depositors(per 1000 adults) of Haiti?
Your response must be concise. -230.96. In the year 2010, what is the difference between the Depositors(per 1000 adults) of Sub-Saharan Africa (all income levels) and Depositors(per 1000 adults) of Uzbekistan?
Provide a short and direct response. -830.23. In the year 2010, what is the difference between the Depositors(per 1000 adults) in Haiti and Depositors(per 1000 adults) in Uzbekistan?
Give a very brief answer. -599.26. In the year 2011, what is the difference between the Depositors(per 1000 adults) in Fragile and conflict affected situations and Depositors(per 1000 adults) in Sub-Saharan Africa (all income levels)?
Give a very brief answer. 19.94. In the year 2011, what is the difference between the Depositors(per 1000 adults) of Fragile and conflict affected situations and Depositors(per 1000 adults) of Haiti?
Offer a terse response. -196.93. In the year 2011, what is the difference between the Depositors(per 1000 adults) in Fragile and conflict affected situations and Depositors(per 1000 adults) in Uzbekistan?
Your answer should be very brief. -783.24. In the year 2011, what is the difference between the Depositors(per 1000 adults) in Sub-Saharan Africa (all income levels) and Depositors(per 1000 adults) in Haiti?
Keep it short and to the point. -216.86. In the year 2011, what is the difference between the Depositors(per 1000 adults) in Sub-Saharan Africa (all income levels) and Depositors(per 1000 adults) in Uzbekistan?
Your answer should be very brief. -803.18. In the year 2011, what is the difference between the Depositors(per 1000 adults) in Haiti and Depositors(per 1000 adults) in Uzbekistan?
Keep it short and to the point. -586.32. In the year 2012, what is the difference between the Depositors(per 1000 adults) in Fragile and conflict affected situations and Depositors(per 1000 adults) in Sub-Saharan Africa (all income levels)?
Provide a succinct answer. 24.24. In the year 2012, what is the difference between the Depositors(per 1000 adults) in Fragile and conflict affected situations and Depositors(per 1000 adults) in Haiti?
Your answer should be compact. -170.12. In the year 2012, what is the difference between the Depositors(per 1000 adults) in Fragile and conflict affected situations and Depositors(per 1000 adults) in Uzbekistan?
Your answer should be very brief. -747.71. In the year 2012, what is the difference between the Depositors(per 1000 adults) in Sub-Saharan Africa (all income levels) and Depositors(per 1000 adults) in Haiti?
Give a very brief answer. -194.35. In the year 2012, what is the difference between the Depositors(per 1000 adults) of Sub-Saharan Africa (all income levels) and Depositors(per 1000 adults) of Uzbekistan?
Provide a succinct answer. -771.94. In the year 2012, what is the difference between the Depositors(per 1000 adults) of Haiti and Depositors(per 1000 adults) of Uzbekistan?
Give a very brief answer. -577.59. What is the ratio of the Depositors(per 1000 adults) of Fragile and conflict affected situations in 2006 to that in 2007?
Provide a succinct answer. 0.98. What is the ratio of the Depositors(per 1000 adults) of Sub-Saharan Africa (all income levels) in 2006 to that in 2007?
Give a very brief answer. 0.83. What is the ratio of the Depositors(per 1000 adults) in Haiti in 2006 to that in 2007?
Provide a succinct answer. 0.9. What is the ratio of the Depositors(per 1000 adults) in Uzbekistan in 2006 to that in 2007?
Your answer should be very brief. 0.94. What is the ratio of the Depositors(per 1000 adults) of Fragile and conflict affected situations in 2006 to that in 2008?
Provide a succinct answer. 0.77. What is the ratio of the Depositors(per 1000 adults) of Sub-Saharan Africa (all income levels) in 2006 to that in 2008?
Provide a succinct answer. 0.73. What is the ratio of the Depositors(per 1000 adults) in Haiti in 2006 to that in 2008?
Provide a succinct answer. 0.83. What is the ratio of the Depositors(per 1000 adults) in Uzbekistan in 2006 to that in 2008?
Offer a very short reply. 0.92. What is the ratio of the Depositors(per 1000 adults) of Fragile and conflict affected situations in 2006 to that in 2009?
Your response must be concise. 0.69. What is the ratio of the Depositors(per 1000 adults) in Sub-Saharan Africa (all income levels) in 2006 to that in 2009?
Offer a terse response. 0.66. What is the ratio of the Depositors(per 1000 adults) of Haiti in 2006 to that in 2009?
Provide a short and direct response. 0.78. What is the ratio of the Depositors(per 1000 adults) in Uzbekistan in 2006 to that in 2009?
Offer a terse response. 0.9. What is the ratio of the Depositors(per 1000 adults) of Fragile and conflict affected situations in 2006 to that in 2010?
Offer a terse response. 0.5. What is the ratio of the Depositors(per 1000 adults) of Sub-Saharan Africa (all income levels) in 2006 to that in 2010?
Provide a succinct answer. 0.57. What is the ratio of the Depositors(per 1000 adults) in Haiti in 2006 to that in 2010?
Make the answer very short. 0.81. What is the ratio of the Depositors(per 1000 adults) in Uzbekistan in 2006 to that in 2010?
Give a very brief answer. 0.87. What is the ratio of the Depositors(per 1000 adults) of Fragile and conflict affected situations in 2006 to that in 2011?
Your response must be concise. 0.53. What is the ratio of the Depositors(per 1000 adults) in Sub-Saharan Africa (all income levels) in 2006 to that in 2011?
Make the answer very short. 0.51. What is the ratio of the Depositors(per 1000 adults) in Haiti in 2006 to that in 2011?
Give a very brief answer. 0.81. What is the ratio of the Depositors(per 1000 adults) of Uzbekistan in 2006 to that in 2011?
Ensure brevity in your answer.  0.89. What is the ratio of the Depositors(per 1000 adults) in Fragile and conflict affected situations in 2006 to that in 2012?
Provide a short and direct response. 0.46. What is the ratio of the Depositors(per 1000 adults) in Sub-Saharan Africa (all income levels) in 2006 to that in 2012?
Keep it short and to the point. 0.44. What is the ratio of the Depositors(per 1000 adults) of Haiti in 2006 to that in 2012?
Make the answer very short. 0.82. What is the ratio of the Depositors(per 1000 adults) of Uzbekistan in 2006 to that in 2012?
Offer a very short reply. 0.9. What is the ratio of the Depositors(per 1000 adults) in Fragile and conflict affected situations in 2007 to that in 2008?
Ensure brevity in your answer.  0.79. What is the ratio of the Depositors(per 1000 adults) of Sub-Saharan Africa (all income levels) in 2007 to that in 2008?
Your response must be concise. 0.88. What is the ratio of the Depositors(per 1000 adults) in Haiti in 2007 to that in 2008?
Your answer should be very brief. 0.92. What is the ratio of the Depositors(per 1000 adults) in Uzbekistan in 2007 to that in 2008?
Keep it short and to the point. 0.98. What is the ratio of the Depositors(per 1000 adults) in Fragile and conflict affected situations in 2007 to that in 2009?
Provide a succinct answer. 0.71. What is the ratio of the Depositors(per 1000 adults) of Sub-Saharan Africa (all income levels) in 2007 to that in 2009?
Offer a terse response. 0.8. What is the ratio of the Depositors(per 1000 adults) of Haiti in 2007 to that in 2009?
Ensure brevity in your answer.  0.86. What is the ratio of the Depositors(per 1000 adults) of Uzbekistan in 2007 to that in 2009?
Provide a short and direct response. 0.96. What is the ratio of the Depositors(per 1000 adults) in Fragile and conflict affected situations in 2007 to that in 2010?
Provide a short and direct response. 0.51. What is the ratio of the Depositors(per 1000 adults) in Sub-Saharan Africa (all income levels) in 2007 to that in 2010?
Your response must be concise. 0.69. What is the ratio of the Depositors(per 1000 adults) in Haiti in 2007 to that in 2010?
Make the answer very short. 0.89. What is the ratio of the Depositors(per 1000 adults) in Uzbekistan in 2007 to that in 2010?
Offer a very short reply. 0.93. What is the ratio of the Depositors(per 1000 adults) of Fragile and conflict affected situations in 2007 to that in 2011?
Offer a terse response. 0.54. What is the ratio of the Depositors(per 1000 adults) of Sub-Saharan Africa (all income levels) in 2007 to that in 2011?
Make the answer very short. 0.62. What is the ratio of the Depositors(per 1000 adults) of Haiti in 2007 to that in 2011?
Keep it short and to the point. 0.9. What is the ratio of the Depositors(per 1000 adults) in Uzbekistan in 2007 to that in 2011?
Provide a short and direct response. 0.95. What is the ratio of the Depositors(per 1000 adults) in Fragile and conflict affected situations in 2007 to that in 2012?
Offer a very short reply. 0.47. What is the ratio of the Depositors(per 1000 adults) in Sub-Saharan Africa (all income levels) in 2007 to that in 2012?
Keep it short and to the point. 0.54. What is the ratio of the Depositors(per 1000 adults) in Haiti in 2007 to that in 2012?
Provide a short and direct response. 0.91. What is the ratio of the Depositors(per 1000 adults) in Uzbekistan in 2007 to that in 2012?
Offer a terse response. 0.96. What is the ratio of the Depositors(per 1000 adults) of Fragile and conflict affected situations in 2008 to that in 2009?
Ensure brevity in your answer.  0.9. What is the ratio of the Depositors(per 1000 adults) in Sub-Saharan Africa (all income levels) in 2008 to that in 2009?
Offer a very short reply. 0.91. What is the ratio of the Depositors(per 1000 adults) in Haiti in 2008 to that in 2009?
Your response must be concise. 0.94. What is the ratio of the Depositors(per 1000 adults) of Fragile and conflict affected situations in 2008 to that in 2010?
Give a very brief answer. 0.65. What is the ratio of the Depositors(per 1000 adults) of Sub-Saharan Africa (all income levels) in 2008 to that in 2010?
Your answer should be compact. 0.78. What is the ratio of the Depositors(per 1000 adults) of Haiti in 2008 to that in 2010?
Offer a terse response. 0.97. What is the ratio of the Depositors(per 1000 adults) of Uzbekistan in 2008 to that in 2010?
Give a very brief answer. 0.95. What is the ratio of the Depositors(per 1000 adults) of Fragile and conflict affected situations in 2008 to that in 2011?
Ensure brevity in your answer.  0.69. What is the ratio of the Depositors(per 1000 adults) of Sub-Saharan Africa (all income levels) in 2008 to that in 2011?
Give a very brief answer. 0.7. What is the ratio of the Depositors(per 1000 adults) in Haiti in 2008 to that in 2011?
Your answer should be compact. 0.98. What is the ratio of the Depositors(per 1000 adults) in Uzbekistan in 2008 to that in 2011?
Offer a very short reply. 0.97. What is the ratio of the Depositors(per 1000 adults) in Fragile and conflict affected situations in 2008 to that in 2012?
Your answer should be very brief. 0.59. What is the ratio of the Depositors(per 1000 adults) in Sub-Saharan Africa (all income levels) in 2008 to that in 2012?
Keep it short and to the point. 0.61. What is the ratio of the Depositors(per 1000 adults) of Haiti in 2008 to that in 2012?
Make the answer very short. 0.99. What is the ratio of the Depositors(per 1000 adults) of Uzbekistan in 2008 to that in 2012?
Offer a very short reply. 0.98. What is the ratio of the Depositors(per 1000 adults) of Fragile and conflict affected situations in 2009 to that in 2010?
Offer a terse response. 0.73. What is the ratio of the Depositors(per 1000 adults) in Sub-Saharan Africa (all income levels) in 2009 to that in 2010?
Offer a terse response. 0.86. What is the ratio of the Depositors(per 1000 adults) in Haiti in 2009 to that in 2010?
Your answer should be very brief. 1.04. What is the ratio of the Depositors(per 1000 adults) in Uzbekistan in 2009 to that in 2010?
Offer a very short reply. 0.97. What is the ratio of the Depositors(per 1000 adults) of Fragile and conflict affected situations in 2009 to that in 2011?
Ensure brevity in your answer.  0.77. What is the ratio of the Depositors(per 1000 adults) of Sub-Saharan Africa (all income levels) in 2009 to that in 2011?
Your answer should be compact. 0.77. What is the ratio of the Depositors(per 1000 adults) in Haiti in 2009 to that in 2011?
Offer a very short reply. 1.04. What is the ratio of the Depositors(per 1000 adults) of Uzbekistan in 2009 to that in 2011?
Your answer should be compact. 0.98. What is the ratio of the Depositors(per 1000 adults) in Fragile and conflict affected situations in 2009 to that in 2012?
Your answer should be very brief. 0.66. What is the ratio of the Depositors(per 1000 adults) of Sub-Saharan Africa (all income levels) in 2009 to that in 2012?
Provide a short and direct response. 0.67. What is the ratio of the Depositors(per 1000 adults) of Haiti in 2009 to that in 2012?
Make the answer very short. 1.06. What is the ratio of the Depositors(per 1000 adults) in Fragile and conflict affected situations in 2010 to that in 2011?
Your answer should be very brief. 1.06. What is the ratio of the Depositors(per 1000 adults) in Sub-Saharan Africa (all income levels) in 2010 to that in 2011?
Offer a terse response. 0.9. What is the ratio of the Depositors(per 1000 adults) in Haiti in 2010 to that in 2011?
Make the answer very short. 1.01. What is the ratio of the Depositors(per 1000 adults) of Uzbekistan in 2010 to that in 2011?
Your answer should be compact. 1.02. What is the ratio of the Depositors(per 1000 adults) of Fragile and conflict affected situations in 2010 to that in 2012?
Your answer should be very brief. 0.91. What is the ratio of the Depositors(per 1000 adults) of Sub-Saharan Africa (all income levels) in 2010 to that in 2012?
Keep it short and to the point. 0.78. What is the ratio of the Depositors(per 1000 adults) of Haiti in 2010 to that in 2012?
Make the answer very short. 1.02. What is the ratio of the Depositors(per 1000 adults) of Uzbekistan in 2010 to that in 2012?
Give a very brief answer. 1.03. What is the ratio of the Depositors(per 1000 adults) in Fragile and conflict affected situations in 2011 to that in 2012?
Keep it short and to the point. 0.86. What is the ratio of the Depositors(per 1000 adults) of Sub-Saharan Africa (all income levels) in 2011 to that in 2012?
Ensure brevity in your answer.  0.87. What is the ratio of the Depositors(per 1000 adults) of Haiti in 2011 to that in 2012?
Your response must be concise. 1.01. What is the ratio of the Depositors(per 1000 adults) of Uzbekistan in 2011 to that in 2012?
Make the answer very short. 1.01. What is the difference between the highest and the second highest Depositors(per 1000 adults) of Fragile and conflict affected situations?
Provide a short and direct response. 14.52. What is the difference between the highest and the second highest Depositors(per 1000 adults) of Sub-Saharan Africa (all income levels)?
Ensure brevity in your answer.  17.98. What is the difference between the highest and the second highest Depositors(per 1000 adults) of Haiti?
Give a very brief answer. 12.38. What is the difference between the highest and the second highest Depositors(per 1000 adults) in Uzbekistan?
Your response must be concise. 14.73. What is the difference between the highest and the lowest Depositors(per 1000 adults) of Fragile and conflict affected situations?
Your answer should be very brief. 87.25. What is the difference between the highest and the lowest Depositors(per 1000 adults) in Sub-Saharan Africa (all income levels)?
Make the answer very short. 76.02. What is the difference between the highest and the lowest Depositors(per 1000 adults) in Haiti?
Make the answer very short. 77.85. What is the difference between the highest and the lowest Depositors(per 1000 adults) in Uzbekistan?
Your answer should be very brief. 118.34. 